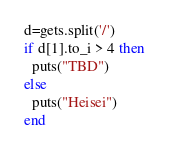<code> <loc_0><loc_0><loc_500><loc_500><_Ruby_>d=gets.split('/')
if d[1].to_i > 4 then 
  puts("TBD")
else
  puts("Heisei")
end
</code> 